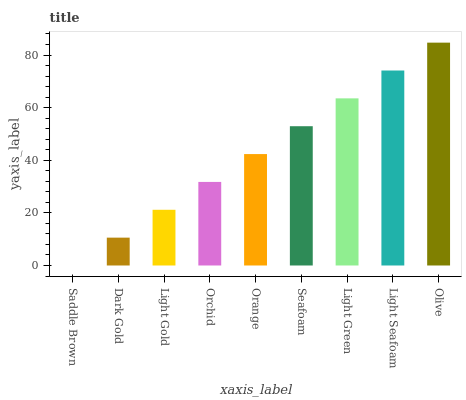Is Saddle Brown the minimum?
Answer yes or no. Yes. Is Olive the maximum?
Answer yes or no. Yes. Is Dark Gold the minimum?
Answer yes or no. No. Is Dark Gold the maximum?
Answer yes or no. No. Is Dark Gold greater than Saddle Brown?
Answer yes or no. Yes. Is Saddle Brown less than Dark Gold?
Answer yes or no. Yes. Is Saddle Brown greater than Dark Gold?
Answer yes or no. No. Is Dark Gold less than Saddle Brown?
Answer yes or no. No. Is Orange the high median?
Answer yes or no. Yes. Is Orange the low median?
Answer yes or no. Yes. Is Orchid the high median?
Answer yes or no. No. Is Orchid the low median?
Answer yes or no. No. 